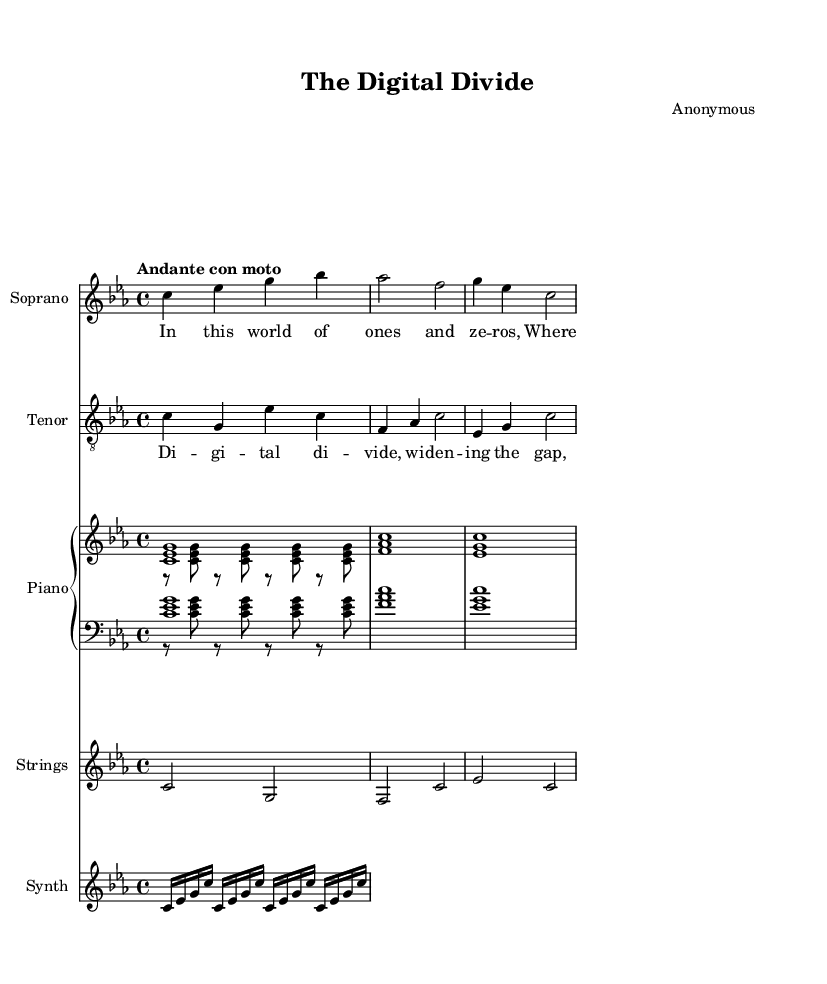What is the key signature of this music? The key signature shows three flats, indicating that this piece is in C minor.
Answer: C minor What is the time signature of this music? The time signature is indicated at the beginning of the score as 4/4, meaning there are four beats in each measure.
Answer: 4/4 What is the tempo marking of this music? The tempo marking "Andante con moto" suggests a moderate tempo that is slightly faster than Andante.
Answer: Andante con moto Which instrument plays the highest pitch in this score? By comparing the written notes, the Soprano voice reaches the highest pitches among the different instruments.
Answer: Soprano How many measures are in the soprano part? There are four measures in the soprano part, as seen by counting the groups of notes and bars.
Answer: Four measures What thematic content is suggested by the lyrics in the verse? The lyrics address the concept of knowledge dissemination in a digital age, emphasizing the merging of technology and information.
Answer: Technology and information What is the role of synthesizer in this piece? The synthesizer adds a modern element characterized by repeated, fast-paced notes that underline the technological theme present in the opera.
Answer: Modern element 